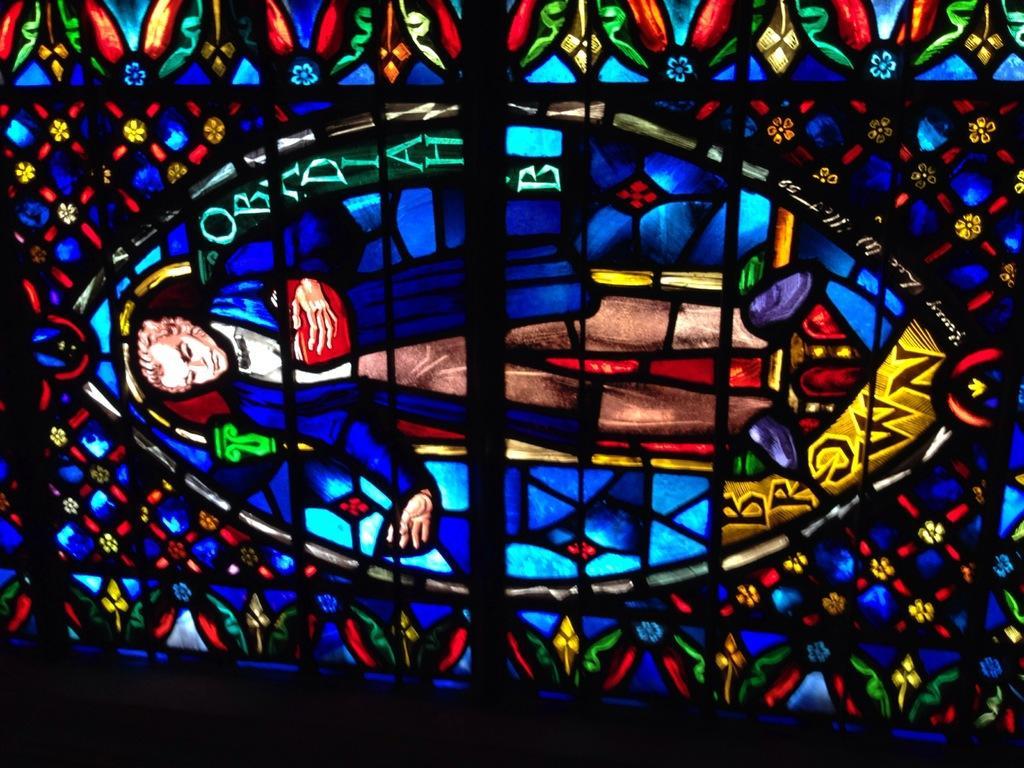Can you describe this image briefly? In this image we can see a stained glass. 